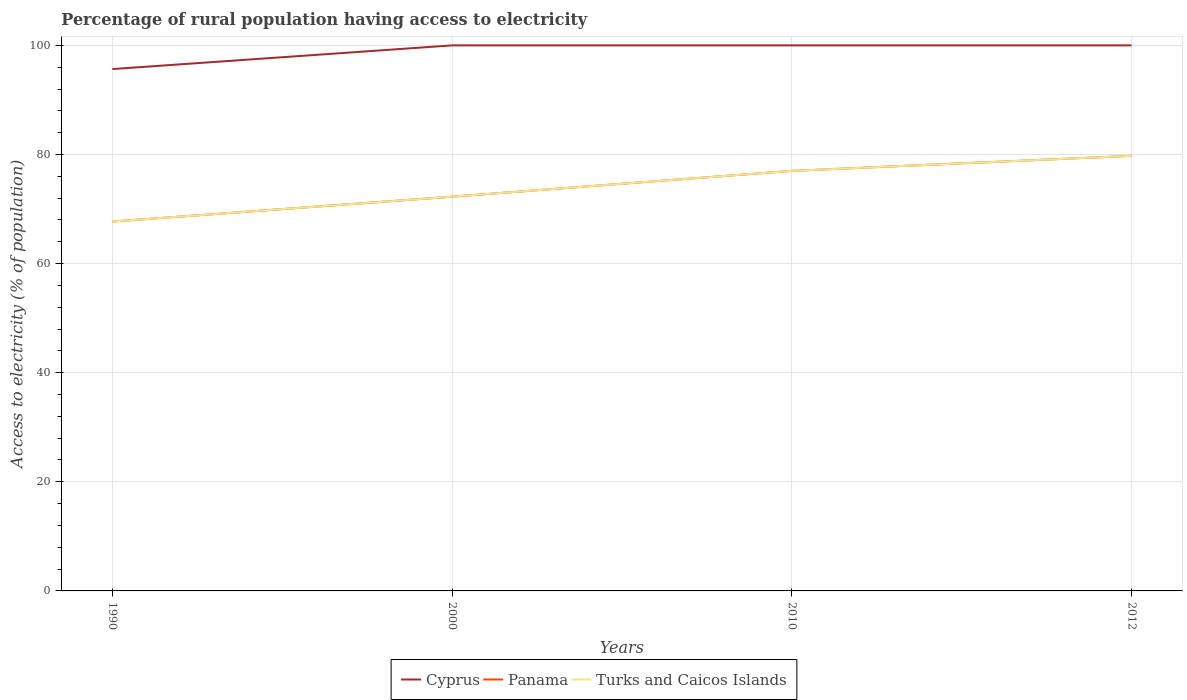Is the number of lines equal to the number of legend labels?
Make the answer very short. Yes. Across all years, what is the maximum percentage of rural population having access to electricity in Cyprus?
Provide a short and direct response. 95.66. In which year was the percentage of rural population having access to electricity in Panama maximum?
Keep it short and to the point. 1990. What is the total percentage of rural population having access to electricity in Panama in the graph?
Ensure brevity in your answer.  -7.49. What is the difference between the highest and the second highest percentage of rural population having access to electricity in Cyprus?
Your answer should be very brief. 4.34. What is the difference between the highest and the lowest percentage of rural population having access to electricity in Turks and Caicos Islands?
Make the answer very short. 2. Is the percentage of rural population having access to electricity in Turks and Caicos Islands strictly greater than the percentage of rural population having access to electricity in Cyprus over the years?
Keep it short and to the point. Yes. How many lines are there?
Your response must be concise. 3. What is the difference between two consecutive major ticks on the Y-axis?
Your answer should be very brief. 20. What is the title of the graph?
Offer a very short reply. Percentage of rural population having access to electricity. Does "Bahamas" appear as one of the legend labels in the graph?
Provide a short and direct response. No. What is the label or title of the Y-axis?
Make the answer very short. Access to electricity (% of population). What is the Access to electricity (% of population) of Cyprus in 1990?
Your answer should be compact. 95.66. What is the Access to electricity (% of population) in Panama in 1990?
Give a very brief answer. 67.71. What is the Access to electricity (% of population) in Turks and Caicos Islands in 1990?
Your response must be concise. 67.71. What is the Access to electricity (% of population) of Panama in 2000?
Your answer should be compact. 72.27. What is the Access to electricity (% of population) of Turks and Caicos Islands in 2000?
Make the answer very short. 72.27. What is the Access to electricity (% of population) in Panama in 2012?
Your answer should be very brief. 79.75. What is the Access to electricity (% of population) in Turks and Caicos Islands in 2012?
Keep it short and to the point. 79.75. Across all years, what is the maximum Access to electricity (% of population) of Panama?
Give a very brief answer. 79.75. Across all years, what is the maximum Access to electricity (% of population) of Turks and Caicos Islands?
Keep it short and to the point. 79.75. Across all years, what is the minimum Access to electricity (% of population) in Cyprus?
Provide a short and direct response. 95.66. Across all years, what is the minimum Access to electricity (% of population) of Panama?
Your answer should be very brief. 67.71. Across all years, what is the minimum Access to electricity (% of population) of Turks and Caicos Islands?
Your response must be concise. 67.71. What is the total Access to electricity (% of population) in Cyprus in the graph?
Provide a short and direct response. 395.66. What is the total Access to electricity (% of population) in Panama in the graph?
Provide a succinct answer. 296.73. What is the total Access to electricity (% of population) in Turks and Caicos Islands in the graph?
Ensure brevity in your answer.  296.73. What is the difference between the Access to electricity (% of population) of Cyprus in 1990 and that in 2000?
Offer a terse response. -4.34. What is the difference between the Access to electricity (% of population) of Panama in 1990 and that in 2000?
Provide a succinct answer. -4.55. What is the difference between the Access to electricity (% of population) in Turks and Caicos Islands in 1990 and that in 2000?
Offer a very short reply. -4.55. What is the difference between the Access to electricity (% of population) in Cyprus in 1990 and that in 2010?
Give a very brief answer. -4.34. What is the difference between the Access to electricity (% of population) of Panama in 1990 and that in 2010?
Keep it short and to the point. -9.29. What is the difference between the Access to electricity (% of population) in Turks and Caicos Islands in 1990 and that in 2010?
Give a very brief answer. -9.29. What is the difference between the Access to electricity (% of population) of Cyprus in 1990 and that in 2012?
Make the answer very short. -4.34. What is the difference between the Access to electricity (% of population) in Panama in 1990 and that in 2012?
Provide a short and direct response. -12.04. What is the difference between the Access to electricity (% of population) in Turks and Caicos Islands in 1990 and that in 2012?
Your answer should be very brief. -12.04. What is the difference between the Access to electricity (% of population) of Panama in 2000 and that in 2010?
Offer a terse response. -4.74. What is the difference between the Access to electricity (% of population) in Turks and Caicos Islands in 2000 and that in 2010?
Give a very brief answer. -4.74. What is the difference between the Access to electricity (% of population) in Cyprus in 2000 and that in 2012?
Your answer should be very brief. 0. What is the difference between the Access to electricity (% of population) in Panama in 2000 and that in 2012?
Offer a terse response. -7.49. What is the difference between the Access to electricity (% of population) in Turks and Caicos Islands in 2000 and that in 2012?
Make the answer very short. -7.49. What is the difference between the Access to electricity (% of population) of Cyprus in 2010 and that in 2012?
Provide a short and direct response. 0. What is the difference between the Access to electricity (% of population) of Panama in 2010 and that in 2012?
Your answer should be very brief. -2.75. What is the difference between the Access to electricity (% of population) in Turks and Caicos Islands in 2010 and that in 2012?
Provide a short and direct response. -2.75. What is the difference between the Access to electricity (% of population) of Cyprus in 1990 and the Access to electricity (% of population) of Panama in 2000?
Give a very brief answer. 23.39. What is the difference between the Access to electricity (% of population) in Cyprus in 1990 and the Access to electricity (% of population) in Turks and Caicos Islands in 2000?
Make the answer very short. 23.39. What is the difference between the Access to electricity (% of population) in Panama in 1990 and the Access to electricity (% of population) in Turks and Caicos Islands in 2000?
Give a very brief answer. -4.55. What is the difference between the Access to electricity (% of population) in Cyprus in 1990 and the Access to electricity (% of population) in Panama in 2010?
Ensure brevity in your answer.  18.66. What is the difference between the Access to electricity (% of population) in Cyprus in 1990 and the Access to electricity (% of population) in Turks and Caicos Islands in 2010?
Provide a succinct answer. 18.66. What is the difference between the Access to electricity (% of population) of Panama in 1990 and the Access to electricity (% of population) of Turks and Caicos Islands in 2010?
Offer a terse response. -9.29. What is the difference between the Access to electricity (% of population) of Cyprus in 1990 and the Access to electricity (% of population) of Panama in 2012?
Your answer should be very brief. 15.91. What is the difference between the Access to electricity (% of population) of Cyprus in 1990 and the Access to electricity (% of population) of Turks and Caicos Islands in 2012?
Make the answer very short. 15.91. What is the difference between the Access to electricity (% of population) in Panama in 1990 and the Access to electricity (% of population) in Turks and Caicos Islands in 2012?
Your response must be concise. -12.04. What is the difference between the Access to electricity (% of population) in Panama in 2000 and the Access to electricity (% of population) in Turks and Caicos Islands in 2010?
Ensure brevity in your answer.  -4.74. What is the difference between the Access to electricity (% of population) of Cyprus in 2000 and the Access to electricity (% of population) of Panama in 2012?
Your answer should be very brief. 20.25. What is the difference between the Access to electricity (% of population) in Cyprus in 2000 and the Access to electricity (% of population) in Turks and Caicos Islands in 2012?
Provide a succinct answer. 20.25. What is the difference between the Access to electricity (% of population) in Panama in 2000 and the Access to electricity (% of population) in Turks and Caicos Islands in 2012?
Keep it short and to the point. -7.49. What is the difference between the Access to electricity (% of population) of Cyprus in 2010 and the Access to electricity (% of population) of Panama in 2012?
Keep it short and to the point. 20.25. What is the difference between the Access to electricity (% of population) of Cyprus in 2010 and the Access to electricity (% of population) of Turks and Caicos Islands in 2012?
Make the answer very short. 20.25. What is the difference between the Access to electricity (% of population) of Panama in 2010 and the Access to electricity (% of population) of Turks and Caicos Islands in 2012?
Provide a short and direct response. -2.75. What is the average Access to electricity (% of population) in Cyprus per year?
Provide a succinct answer. 98.92. What is the average Access to electricity (% of population) of Panama per year?
Provide a short and direct response. 74.18. What is the average Access to electricity (% of population) of Turks and Caicos Islands per year?
Make the answer very short. 74.18. In the year 1990, what is the difference between the Access to electricity (% of population) of Cyprus and Access to electricity (% of population) of Panama?
Ensure brevity in your answer.  27.95. In the year 1990, what is the difference between the Access to electricity (% of population) in Cyprus and Access to electricity (% of population) in Turks and Caicos Islands?
Ensure brevity in your answer.  27.95. In the year 2000, what is the difference between the Access to electricity (% of population) in Cyprus and Access to electricity (% of population) in Panama?
Your answer should be very brief. 27.73. In the year 2000, what is the difference between the Access to electricity (% of population) in Cyprus and Access to electricity (% of population) in Turks and Caicos Islands?
Provide a short and direct response. 27.73. In the year 2010, what is the difference between the Access to electricity (% of population) of Cyprus and Access to electricity (% of population) of Panama?
Provide a short and direct response. 23. In the year 2010, what is the difference between the Access to electricity (% of population) of Cyprus and Access to electricity (% of population) of Turks and Caicos Islands?
Offer a very short reply. 23. In the year 2012, what is the difference between the Access to electricity (% of population) of Cyprus and Access to electricity (% of population) of Panama?
Offer a terse response. 20.25. In the year 2012, what is the difference between the Access to electricity (% of population) in Cyprus and Access to electricity (% of population) in Turks and Caicos Islands?
Your answer should be very brief. 20.25. In the year 2012, what is the difference between the Access to electricity (% of population) of Panama and Access to electricity (% of population) of Turks and Caicos Islands?
Ensure brevity in your answer.  0. What is the ratio of the Access to electricity (% of population) in Cyprus in 1990 to that in 2000?
Offer a very short reply. 0.96. What is the ratio of the Access to electricity (% of population) of Panama in 1990 to that in 2000?
Offer a very short reply. 0.94. What is the ratio of the Access to electricity (% of population) in Turks and Caicos Islands in 1990 to that in 2000?
Offer a very short reply. 0.94. What is the ratio of the Access to electricity (% of population) of Cyprus in 1990 to that in 2010?
Give a very brief answer. 0.96. What is the ratio of the Access to electricity (% of population) of Panama in 1990 to that in 2010?
Keep it short and to the point. 0.88. What is the ratio of the Access to electricity (% of population) of Turks and Caicos Islands in 1990 to that in 2010?
Keep it short and to the point. 0.88. What is the ratio of the Access to electricity (% of population) of Cyprus in 1990 to that in 2012?
Ensure brevity in your answer.  0.96. What is the ratio of the Access to electricity (% of population) in Panama in 1990 to that in 2012?
Your response must be concise. 0.85. What is the ratio of the Access to electricity (% of population) of Turks and Caicos Islands in 1990 to that in 2012?
Make the answer very short. 0.85. What is the ratio of the Access to electricity (% of population) of Cyprus in 2000 to that in 2010?
Your answer should be compact. 1. What is the ratio of the Access to electricity (% of population) in Panama in 2000 to that in 2010?
Give a very brief answer. 0.94. What is the ratio of the Access to electricity (% of population) in Turks and Caicos Islands in 2000 to that in 2010?
Provide a short and direct response. 0.94. What is the ratio of the Access to electricity (% of population) of Panama in 2000 to that in 2012?
Offer a terse response. 0.91. What is the ratio of the Access to electricity (% of population) of Turks and Caicos Islands in 2000 to that in 2012?
Your response must be concise. 0.91. What is the ratio of the Access to electricity (% of population) in Cyprus in 2010 to that in 2012?
Your answer should be very brief. 1. What is the ratio of the Access to electricity (% of population) of Panama in 2010 to that in 2012?
Provide a succinct answer. 0.97. What is the ratio of the Access to electricity (% of population) of Turks and Caicos Islands in 2010 to that in 2012?
Ensure brevity in your answer.  0.97. What is the difference between the highest and the second highest Access to electricity (% of population) of Panama?
Provide a short and direct response. 2.75. What is the difference between the highest and the second highest Access to electricity (% of population) of Turks and Caicos Islands?
Provide a succinct answer. 2.75. What is the difference between the highest and the lowest Access to electricity (% of population) of Cyprus?
Give a very brief answer. 4.34. What is the difference between the highest and the lowest Access to electricity (% of population) in Panama?
Keep it short and to the point. 12.04. What is the difference between the highest and the lowest Access to electricity (% of population) of Turks and Caicos Islands?
Your response must be concise. 12.04. 